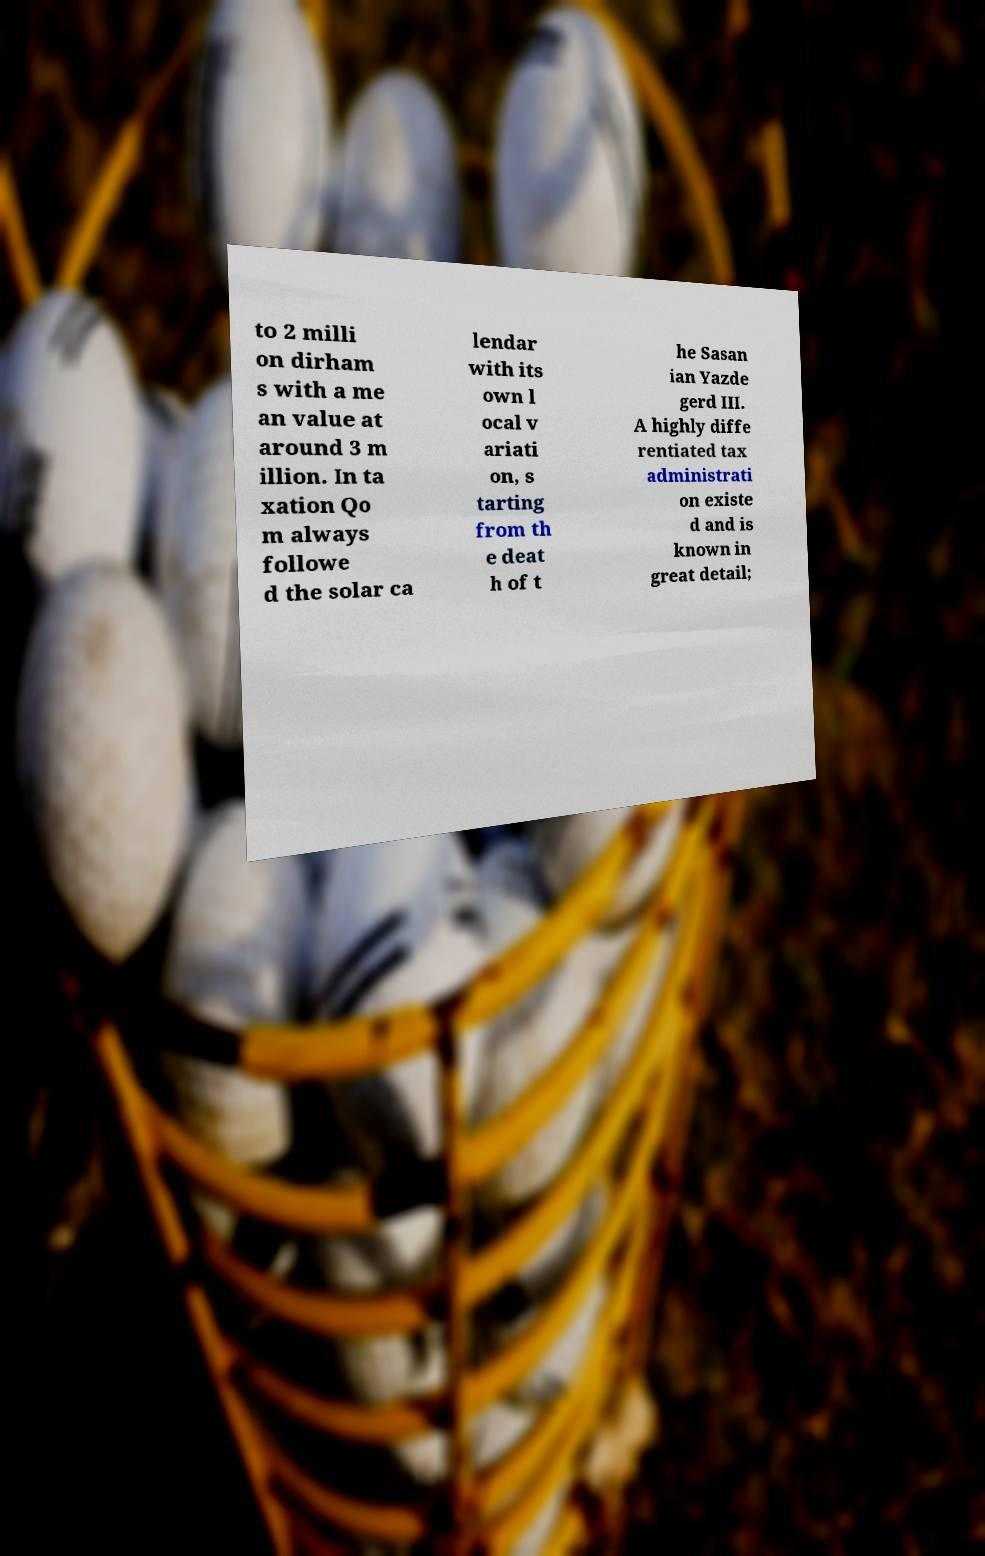Can you accurately transcribe the text from the provided image for me? to 2 milli on dirham s with a me an value at around 3 m illion. In ta xation Qo m always followe d the solar ca lendar with its own l ocal v ariati on, s tarting from th e deat h of t he Sasan ian Yazde gerd III. A highly diffe rentiated tax administrati on existe d and is known in great detail; 